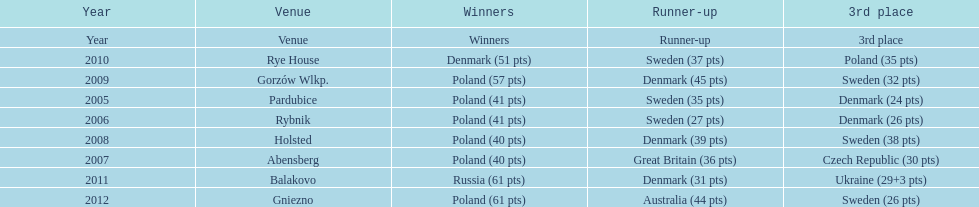What was the difference in final score between russia and denmark in 2011? 30. 